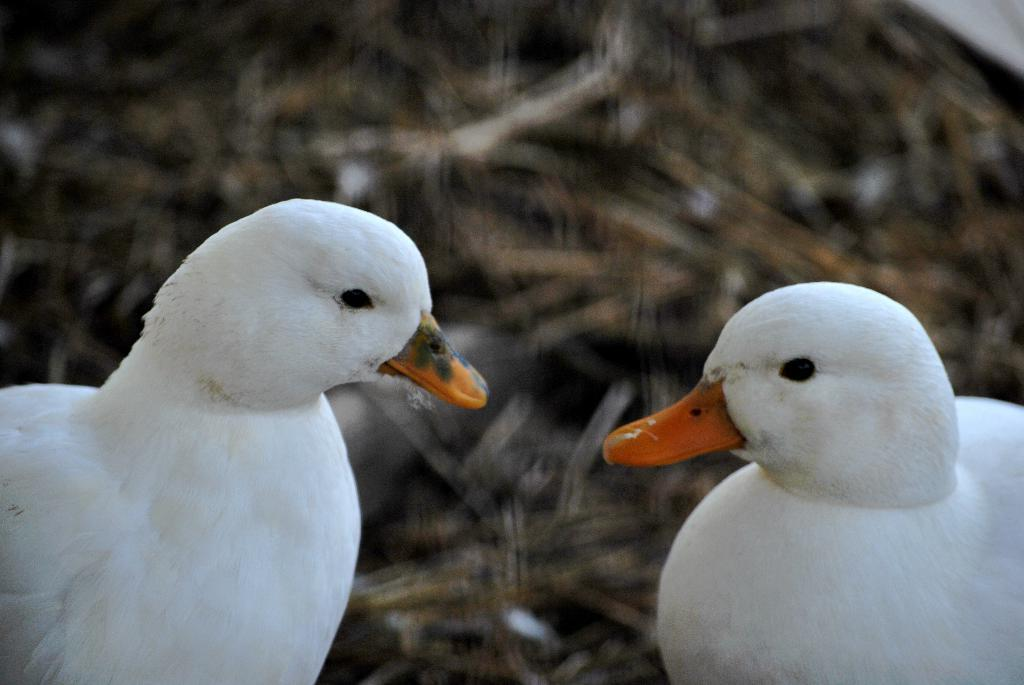How many birds are present in the image? There are two birds in the image. Can you describe the background of the image? The background of the image is blurry. What type of design can be seen on the pie in the image? There is no pie present in the image; it only features two birds. What type of airplane is visible in the image? There is no airplane present in the image; it only features two birds. 